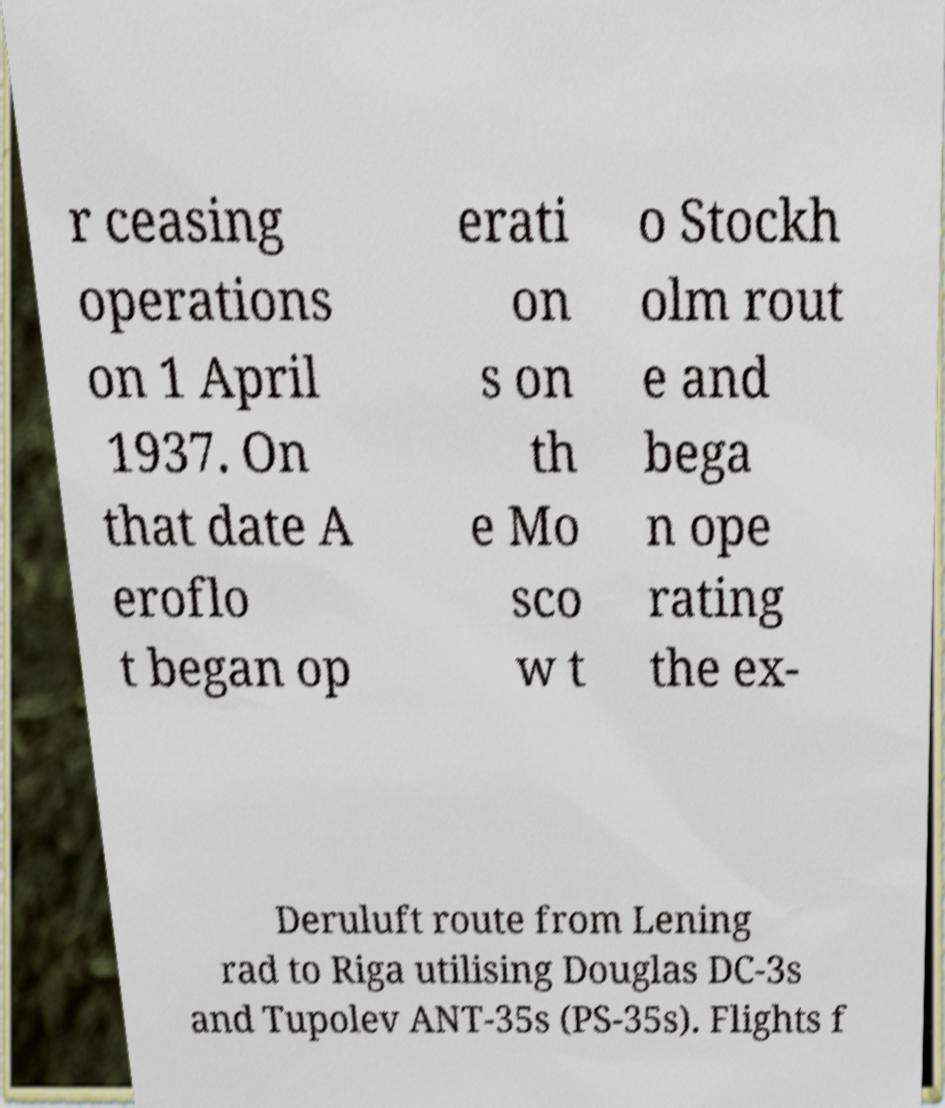Please read and relay the text visible in this image. What does it say? r ceasing operations on 1 April 1937. On that date A eroflo t began op erati on s on th e Mo sco w t o Stockh olm rout e and bega n ope rating the ex- Deruluft route from Lening rad to Riga utilising Douglas DC-3s and Tupolev ANT-35s (PS-35s). Flights f 